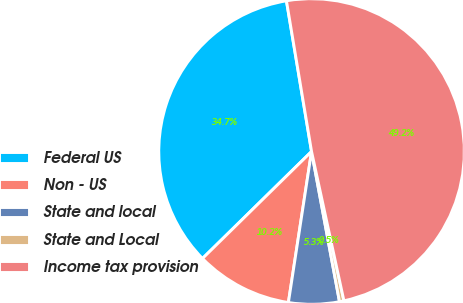Convert chart to OTSL. <chart><loc_0><loc_0><loc_500><loc_500><pie_chart><fcel>Federal US<fcel>Non - US<fcel>State and local<fcel>State and Local<fcel>Income tax provision<nl><fcel>34.72%<fcel>10.23%<fcel>5.35%<fcel>0.47%<fcel>49.23%<nl></chart> 